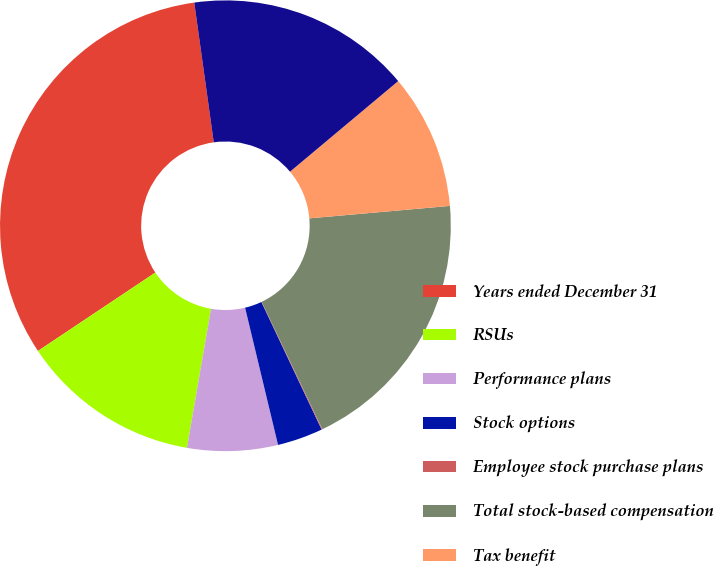Convert chart. <chart><loc_0><loc_0><loc_500><loc_500><pie_chart><fcel>Years ended December 31<fcel>RSUs<fcel>Performance plans<fcel>Stock options<fcel>Employee stock purchase plans<fcel>Total stock-based compensation<fcel>Tax benefit<fcel>Stock-based compensation<nl><fcel>32.16%<fcel>12.9%<fcel>6.48%<fcel>3.27%<fcel>0.06%<fcel>19.32%<fcel>9.69%<fcel>16.11%<nl></chart> 